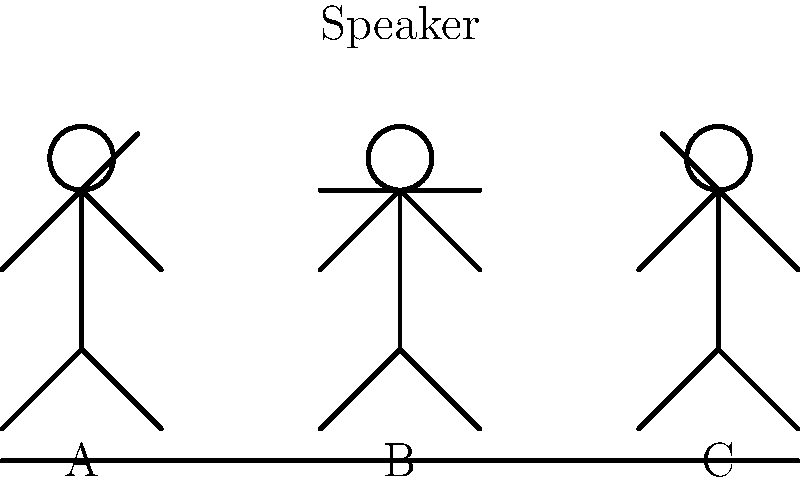In a business meeting, three participants (A, B, and C) are seated at a table while someone is speaking. Based on their body language as shown in the stick figure diagram, which participant is likely the most engaged and receptive to the speaker's message? To interpret the body language cues in this business meeting scenario, let's analyze each participant's posture:

1. Participant A:
   - Arms are angled upwards at approximately 45 degrees
   - This open posture suggests attentiveness and engagement
   - Upward arm angle may indicate agreement or enthusiasm

2. Participant B:
   - Arms are positioned straight out, parallel to the table
   - This neutral posture suggests listening but not necessarily strong engagement
   - May indicate a more reserved or cautious approach to the discussion

3. Participant C:
   - Arms are angled downwards at approximately 45 degrees
   - This closed posture can suggest discomfort, disagreement, or disengagement
   - Downward arm angle may indicate skepticism or defensiveness

Comparing these postures:
- Open postures (like A's) generally indicate higher levels of engagement and receptivity
- Neutral postures (like B's) suggest moderate engagement
- Closed postures (like C's) often indicate lower levels of engagement or possible resistance

Therefore, based on the body language cues presented in the stick figure diagram, Participant A is likely the most engaged and receptive to the speaker's message due to their open and upward-angled arm posture.
Answer: Participant A 